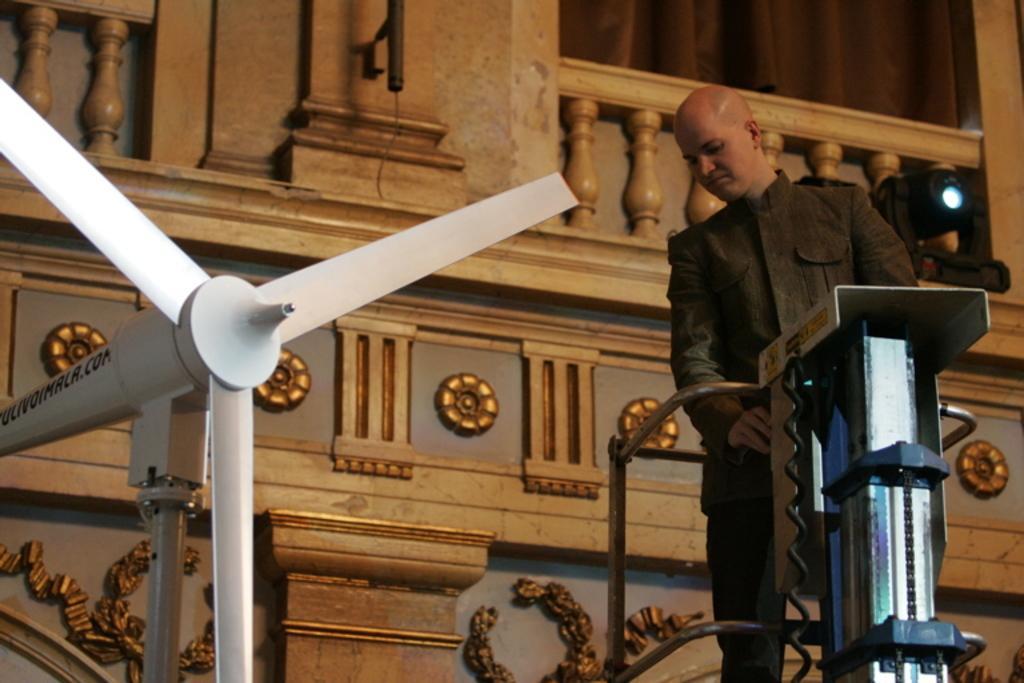In one or two sentences, can you explain what this image depicts? In this image I can see a person standing on the machine beside him there is a there is a fan which looks like wind turbine. 